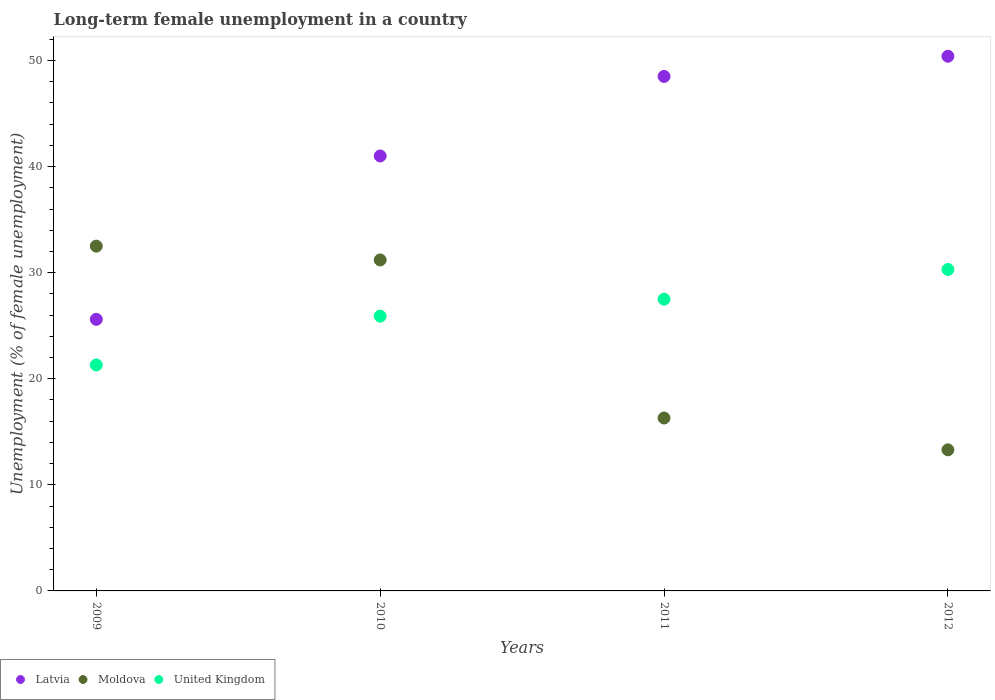How many different coloured dotlines are there?
Your answer should be very brief. 3. Is the number of dotlines equal to the number of legend labels?
Give a very brief answer. Yes. What is the percentage of long-term unemployed female population in Latvia in 2010?
Your answer should be very brief. 41. Across all years, what is the maximum percentage of long-term unemployed female population in Moldova?
Make the answer very short. 32.5. Across all years, what is the minimum percentage of long-term unemployed female population in Latvia?
Your answer should be very brief. 25.6. What is the total percentage of long-term unemployed female population in Latvia in the graph?
Ensure brevity in your answer.  165.5. What is the difference between the percentage of long-term unemployed female population in Latvia in 2009 and that in 2012?
Offer a very short reply. -24.8. What is the difference between the percentage of long-term unemployed female population in United Kingdom in 2011 and the percentage of long-term unemployed female population in Latvia in 2012?
Give a very brief answer. -22.9. What is the average percentage of long-term unemployed female population in Latvia per year?
Your answer should be compact. 41.38. In the year 2011, what is the difference between the percentage of long-term unemployed female population in United Kingdom and percentage of long-term unemployed female population in Latvia?
Offer a very short reply. -21. What is the ratio of the percentage of long-term unemployed female population in Moldova in 2010 to that in 2012?
Your answer should be compact. 2.35. Is the percentage of long-term unemployed female population in Moldova in 2011 less than that in 2012?
Provide a short and direct response. No. Is the difference between the percentage of long-term unemployed female population in United Kingdom in 2009 and 2011 greater than the difference between the percentage of long-term unemployed female population in Latvia in 2009 and 2011?
Ensure brevity in your answer.  Yes. What is the difference between the highest and the second highest percentage of long-term unemployed female population in Latvia?
Provide a short and direct response. 1.9. What is the difference between the highest and the lowest percentage of long-term unemployed female population in Moldova?
Provide a succinct answer. 19.2. Is the sum of the percentage of long-term unemployed female population in Latvia in 2009 and 2010 greater than the maximum percentage of long-term unemployed female population in United Kingdom across all years?
Your response must be concise. Yes. Is the percentage of long-term unemployed female population in Moldova strictly less than the percentage of long-term unemployed female population in Latvia over the years?
Provide a short and direct response. No. How many years are there in the graph?
Make the answer very short. 4. How many legend labels are there?
Ensure brevity in your answer.  3. How are the legend labels stacked?
Provide a succinct answer. Horizontal. What is the title of the graph?
Offer a very short reply. Long-term female unemployment in a country. What is the label or title of the Y-axis?
Make the answer very short. Unemployment (% of female unemployment). What is the Unemployment (% of female unemployment) in Latvia in 2009?
Provide a short and direct response. 25.6. What is the Unemployment (% of female unemployment) in Moldova in 2009?
Make the answer very short. 32.5. What is the Unemployment (% of female unemployment) in United Kingdom in 2009?
Provide a short and direct response. 21.3. What is the Unemployment (% of female unemployment) of Latvia in 2010?
Offer a very short reply. 41. What is the Unemployment (% of female unemployment) in Moldova in 2010?
Ensure brevity in your answer.  31.2. What is the Unemployment (% of female unemployment) of United Kingdom in 2010?
Your answer should be compact. 25.9. What is the Unemployment (% of female unemployment) of Latvia in 2011?
Provide a short and direct response. 48.5. What is the Unemployment (% of female unemployment) in Moldova in 2011?
Your answer should be very brief. 16.3. What is the Unemployment (% of female unemployment) in United Kingdom in 2011?
Give a very brief answer. 27.5. What is the Unemployment (% of female unemployment) of Latvia in 2012?
Give a very brief answer. 50.4. What is the Unemployment (% of female unemployment) of Moldova in 2012?
Your answer should be compact. 13.3. What is the Unemployment (% of female unemployment) in United Kingdom in 2012?
Keep it short and to the point. 30.3. Across all years, what is the maximum Unemployment (% of female unemployment) in Latvia?
Keep it short and to the point. 50.4. Across all years, what is the maximum Unemployment (% of female unemployment) of Moldova?
Offer a very short reply. 32.5. Across all years, what is the maximum Unemployment (% of female unemployment) of United Kingdom?
Your answer should be compact. 30.3. Across all years, what is the minimum Unemployment (% of female unemployment) of Latvia?
Your answer should be very brief. 25.6. Across all years, what is the minimum Unemployment (% of female unemployment) in Moldova?
Your response must be concise. 13.3. Across all years, what is the minimum Unemployment (% of female unemployment) in United Kingdom?
Your answer should be compact. 21.3. What is the total Unemployment (% of female unemployment) of Latvia in the graph?
Ensure brevity in your answer.  165.5. What is the total Unemployment (% of female unemployment) of Moldova in the graph?
Make the answer very short. 93.3. What is the total Unemployment (% of female unemployment) of United Kingdom in the graph?
Make the answer very short. 105. What is the difference between the Unemployment (% of female unemployment) in Latvia in 2009 and that in 2010?
Your response must be concise. -15.4. What is the difference between the Unemployment (% of female unemployment) of Latvia in 2009 and that in 2011?
Your response must be concise. -22.9. What is the difference between the Unemployment (% of female unemployment) of Moldova in 2009 and that in 2011?
Provide a succinct answer. 16.2. What is the difference between the Unemployment (% of female unemployment) of Latvia in 2009 and that in 2012?
Offer a very short reply. -24.8. What is the difference between the Unemployment (% of female unemployment) of Moldova in 2009 and that in 2012?
Provide a succinct answer. 19.2. What is the difference between the Unemployment (% of female unemployment) in Latvia in 2010 and that in 2011?
Your response must be concise. -7.5. What is the difference between the Unemployment (% of female unemployment) in United Kingdom in 2010 and that in 2011?
Your answer should be compact. -1.6. What is the difference between the Unemployment (% of female unemployment) in Moldova in 2011 and that in 2012?
Ensure brevity in your answer.  3. What is the difference between the Unemployment (% of female unemployment) of Latvia in 2009 and the Unemployment (% of female unemployment) of Moldova in 2010?
Your answer should be very brief. -5.6. What is the difference between the Unemployment (% of female unemployment) in Latvia in 2009 and the Unemployment (% of female unemployment) in Moldova in 2011?
Provide a short and direct response. 9.3. What is the difference between the Unemployment (% of female unemployment) in Latvia in 2009 and the Unemployment (% of female unemployment) in United Kingdom in 2011?
Offer a terse response. -1.9. What is the difference between the Unemployment (% of female unemployment) of Moldova in 2009 and the Unemployment (% of female unemployment) of United Kingdom in 2011?
Your answer should be compact. 5. What is the difference between the Unemployment (% of female unemployment) in Latvia in 2009 and the Unemployment (% of female unemployment) in Moldova in 2012?
Your answer should be compact. 12.3. What is the difference between the Unemployment (% of female unemployment) of Moldova in 2009 and the Unemployment (% of female unemployment) of United Kingdom in 2012?
Offer a very short reply. 2.2. What is the difference between the Unemployment (% of female unemployment) in Latvia in 2010 and the Unemployment (% of female unemployment) in Moldova in 2011?
Your response must be concise. 24.7. What is the difference between the Unemployment (% of female unemployment) in Latvia in 2010 and the Unemployment (% of female unemployment) in United Kingdom in 2011?
Your response must be concise. 13.5. What is the difference between the Unemployment (% of female unemployment) of Moldova in 2010 and the Unemployment (% of female unemployment) of United Kingdom in 2011?
Offer a very short reply. 3.7. What is the difference between the Unemployment (% of female unemployment) in Latvia in 2010 and the Unemployment (% of female unemployment) in Moldova in 2012?
Offer a very short reply. 27.7. What is the difference between the Unemployment (% of female unemployment) in Latvia in 2011 and the Unemployment (% of female unemployment) in Moldova in 2012?
Your response must be concise. 35.2. What is the average Unemployment (% of female unemployment) in Latvia per year?
Give a very brief answer. 41.38. What is the average Unemployment (% of female unemployment) in Moldova per year?
Ensure brevity in your answer.  23.32. What is the average Unemployment (% of female unemployment) in United Kingdom per year?
Provide a succinct answer. 26.25. In the year 2009, what is the difference between the Unemployment (% of female unemployment) of Latvia and Unemployment (% of female unemployment) of United Kingdom?
Make the answer very short. 4.3. In the year 2010, what is the difference between the Unemployment (% of female unemployment) in Moldova and Unemployment (% of female unemployment) in United Kingdom?
Ensure brevity in your answer.  5.3. In the year 2011, what is the difference between the Unemployment (% of female unemployment) of Latvia and Unemployment (% of female unemployment) of Moldova?
Ensure brevity in your answer.  32.2. In the year 2011, what is the difference between the Unemployment (% of female unemployment) in Latvia and Unemployment (% of female unemployment) in United Kingdom?
Provide a succinct answer. 21. In the year 2012, what is the difference between the Unemployment (% of female unemployment) in Latvia and Unemployment (% of female unemployment) in Moldova?
Your answer should be very brief. 37.1. In the year 2012, what is the difference between the Unemployment (% of female unemployment) of Latvia and Unemployment (% of female unemployment) of United Kingdom?
Provide a succinct answer. 20.1. In the year 2012, what is the difference between the Unemployment (% of female unemployment) in Moldova and Unemployment (% of female unemployment) in United Kingdom?
Your answer should be very brief. -17. What is the ratio of the Unemployment (% of female unemployment) in Latvia in 2009 to that in 2010?
Provide a short and direct response. 0.62. What is the ratio of the Unemployment (% of female unemployment) of Moldova in 2009 to that in 2010?
Provide a short and direct response. 1.04. What is the ratio of the Unemployment (% of female unemployment) of United Kingdom in 2009 to that in 2010?
Make the answer very short. 0.82. What is the ratio of the Unemployment (% of female unemployment) of Latvia in 2009 to that in 2011?
Your response must be concise. 0.53. What is the ratio of the Unemployment (% of female unemployment) of Moldova in 2009 to that in 2011?
Your answer should be compact. 1.99. What is the ratio of the Unemployment (% of female unemployment) in United Kingdom in 2009 to that in 2011?
Your answer should be very brief. 0.77. What is the ratio of the Unemployment (% of female unemployment) in Latvia in 2009 to that in 2012?
Offer a terse response. 0.51. What is the ratio of the Unemployment (% of female unemployment) of Moldova in 2009 to that in 2012?
Give a very brief answer. 2.44. What is the ratio of the Unemployment (% of female unemployment) of United Kingdom in 2009 to that in 2012?
Provide a succinct answer. 0.7. What is the ratio of the Unemployment (% of female unemployment) of Latvia in 2010 to that in 2011?
Your answer should be very brief. 0.85. What is the ratio of the Unemployment (% of female unemployment) of Moldova in 2010 to that in 2011?
Make the answer very short. 1.91. What is the ratio of the Unemployment (% of female unemployment) in United Kingdom in 2010 to that in 2011?
Offer a very short reply. 0.94. What is the ratio of the Unemployment (% of female unemployment) of Latvia in 2010 to that in 2012?
Provide a short and direct response. 0.81. What is the ratio of the Unemployment (% of female unemployment) in Moldova in 2010 to that in 2012?
Provide a short and direct response. 2.35. What is the ratio of the Unemployment (% of female unemployment) of United Kingdom in 2010 to that in 2012?
Offer a terse response. 0.85. What is the ratio of the Unemployment (% of female unemployment) in Latvia in 2011 to that in 2012?
Your answer should be very brief. 0.96. What is the ratio of the Unemployment (% of female unemployment) of Moldova in 2011 to that in 2012?
Ensure brevity in your answer.  1.23. What is the ratio of the Unemployment (% of female unemployment) of United Kingdom in 2011 to that in 2012?
Your answer should be compact. 0.91. What is the difference between the highest and the second highest Unemployment (% of female unemployment) of Latvia?
Make the answer very short. 1.9. What is the difference between the highest and the second highest Unemployment (% of female unemployment) of Moldova?
Give a very brief answer. 1.3. What is the difference between the highest and the second highest Unemployment (% of female unemployment) in United Kingdom?
Keep it short and to the point. 2.8. What is the difference between the highest and the lowest Unemployment (% of female unemployment) in Latvia?
Provide a succinct answer. 24.8. What is the difference between the highest and the lowest Unemployment (% of female unemployment) in Moldova?
Keep it short and to the point. 19.2. What is the difference between the highest and the lowest Unemployment (% of female unemployment) of United Kingdom?
Keep it short and to the point. 9. 